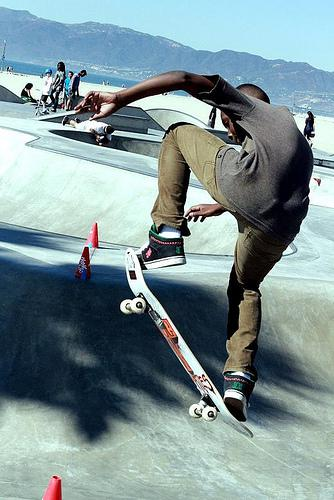Question: what are the people doing in the photo?
Choices:
A. Talking.
B. Skateboarding.
C. Laughing.
D. Dancing.
Answer with the letter. Answer: B Question: where was this photo taken?
Choices:
A. A home.
B. A church.
C. A skateboard park.
D. A school.
Answer with the letter. Answer: C Question: how many cones are in the photo?
Choices:
A. 3.
B. 1.
C. 2.
D. 4.
Answer with the letter. Answer: A Question: when was this photo taken?
Choices:
A. Early morning.
B. Midnight.
C. In the daytime.
D. Late night.
Answer with the letter. Answer: C Question: who is in this photo?
Choices:
A. Skiers.
B. Skateboarders.
C. Readers.
D. Laughers.
Answer with the letter. Answer: B Question: what color is the sky?
Choices:
A. White.
B. Black.
C. Gray.
D. Blue.
Answer with the letter. Answer: D Question: why was this photo taken?
Choices:
A. To show skateboarders.
B. To show skiers.
C. To show trees.
D. To show snow.
Answer with the letter. Answer: A 